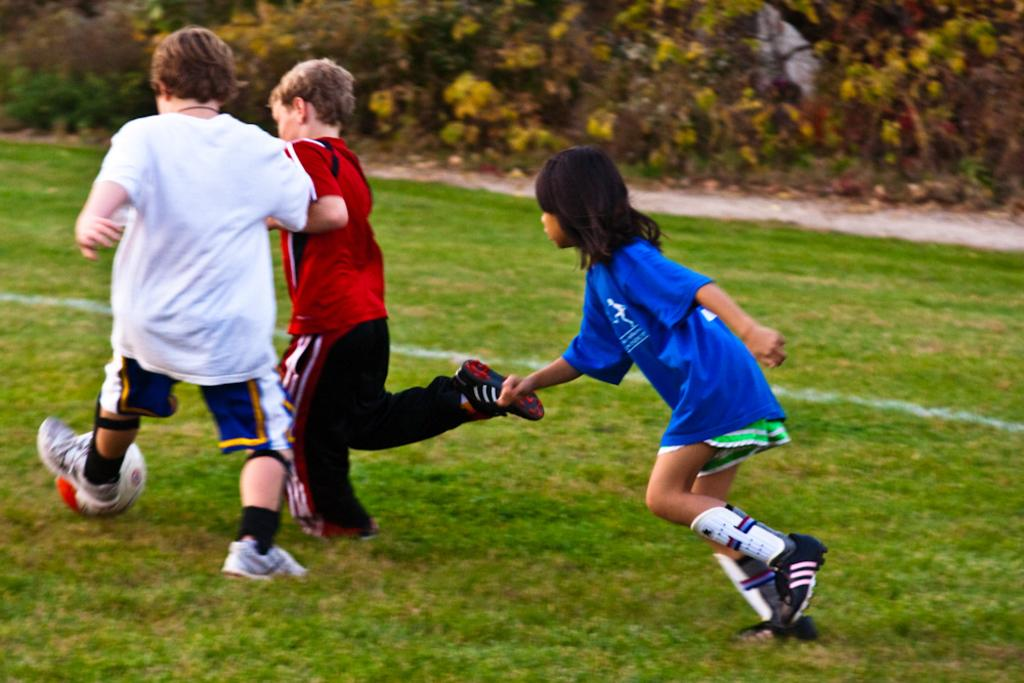How many kids are in the image? There are three kids in the image. What are the kids doing in the image? The kids are playing a game with a ball. Where is the game being played? The game is being played on the grass. What can be seen at the top of the image? There are plants visible at the top of the image. What type of canvas is visible in the image? There is no canvas present in the image. 